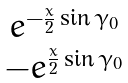Convert formula to latex. <formula><loc_0><loc_0><loc_500><loc_500>\begin{matrix} e ^ { - \frac { x } { 2 } \sin \gamma _ { 0 } } \\ - e ^ { \frac { x } { 2 } \sin \gamma _ { 0 } } \end{matrix}</formula> 